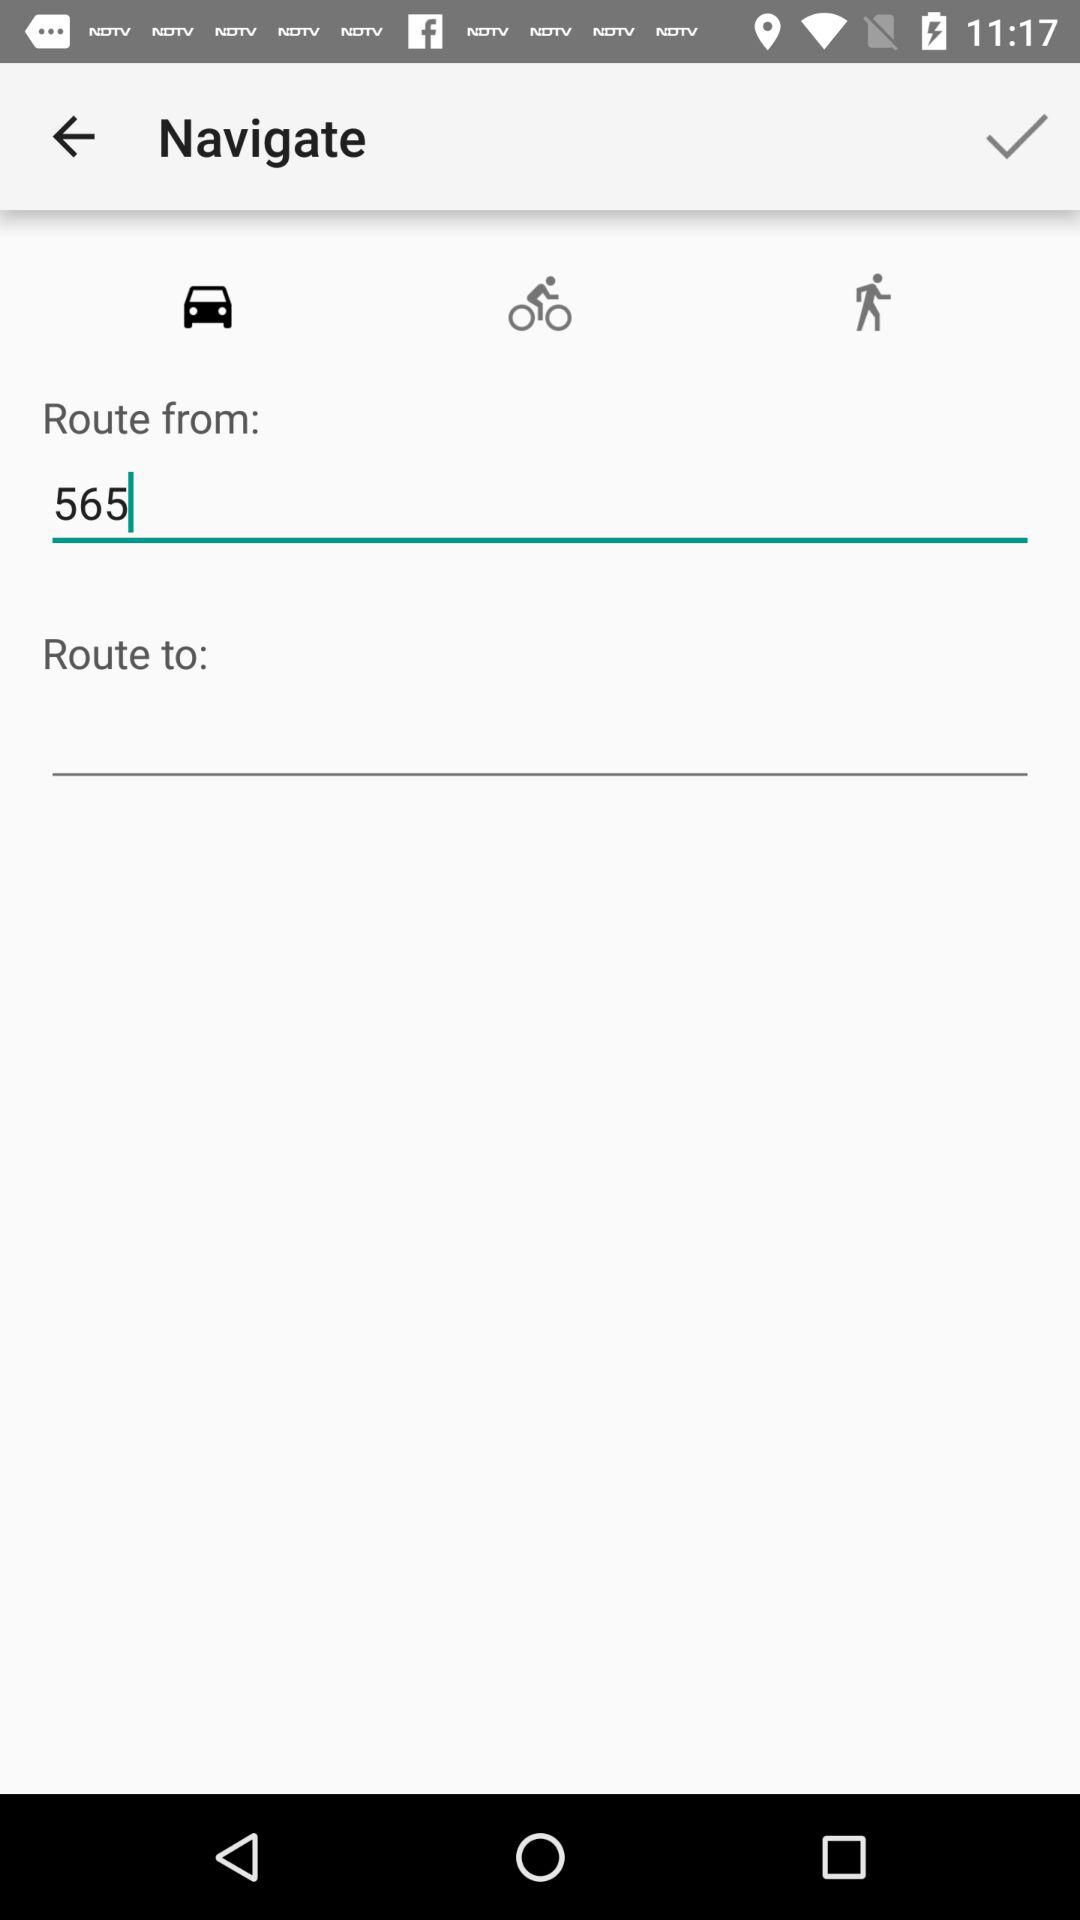What is the number entered in "Route from"? The number is 565. 